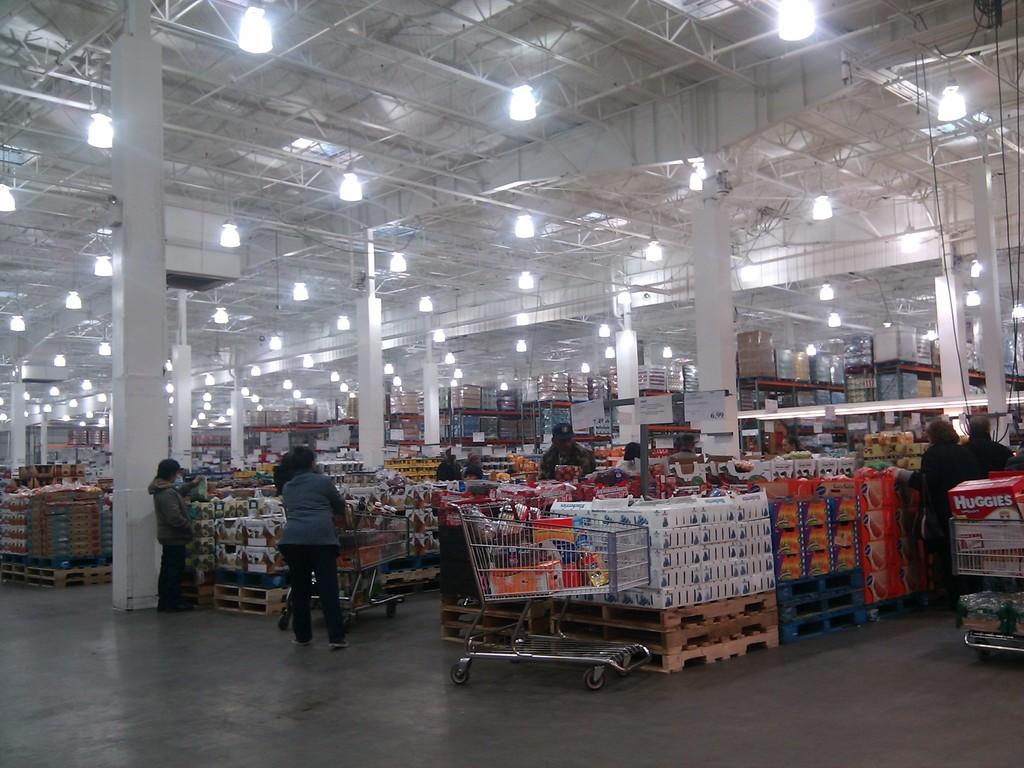<image>
Present a compact description of the photo's key features. a box of huggies is in the cart of a person at a big store 